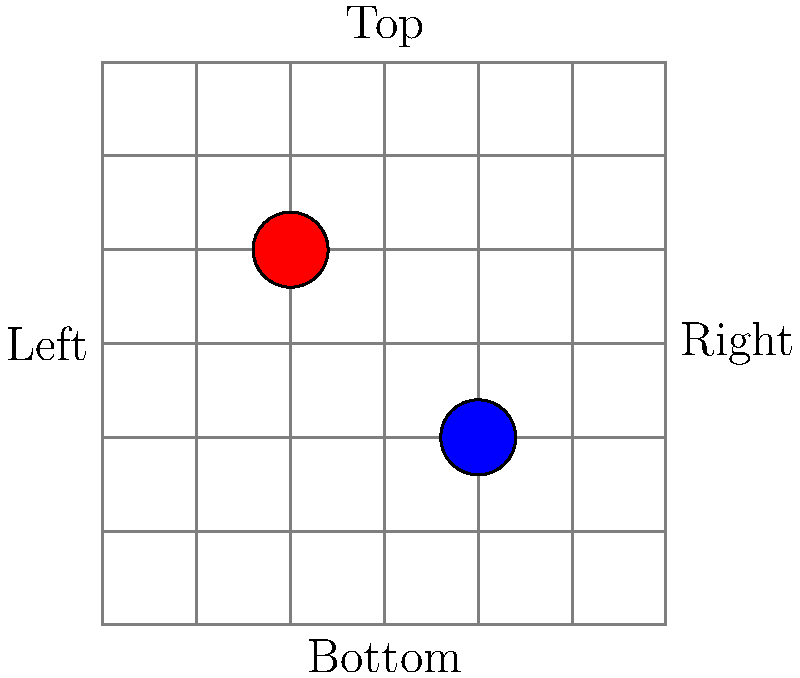Analyze the product placement in this print ad grid overlay diagram. Which quadrant is most likely to attract immediate attention based on eye-tracking studies, and what does this suggest about the red product's positioning? To answer this question, we need to consider several factors:

1. Eye-tracking studies have shown that people tend to view print ads in an F-shaped pattern, starting from the top-left corner.

2. The grid overlay divides the ad space into four quadrants:
   - Top-left (Q1)
   - Top-right (Q2)
   - Bottom-left (Q3)
   - Bottom-right (Q4)

3. In this diagram, we see two products:
   - A red product in the top-left quadrant (Q1)
   - A blue product in the bottom-right quadrant (Q4)

4. The top-left quadrant (Q1) typically receives the most immediate attention due to the F-shaped viewing pattern.

5. The red product is positioned in Q1, which suggests it is strategically placed to capture the viewer's attention first.

6. This placement implies that the red product is likely the primary focus of the advertisement or the more important of the two products shown.

Given this analysis, we can conclude that the top-left quadrant (Q1) is most likely to attract immediate attention, and the red product's positioning in this quadrant suggests it is intended to be the first and main focus of the viewer.
Answer: Top-left quadrant; primary product focus 